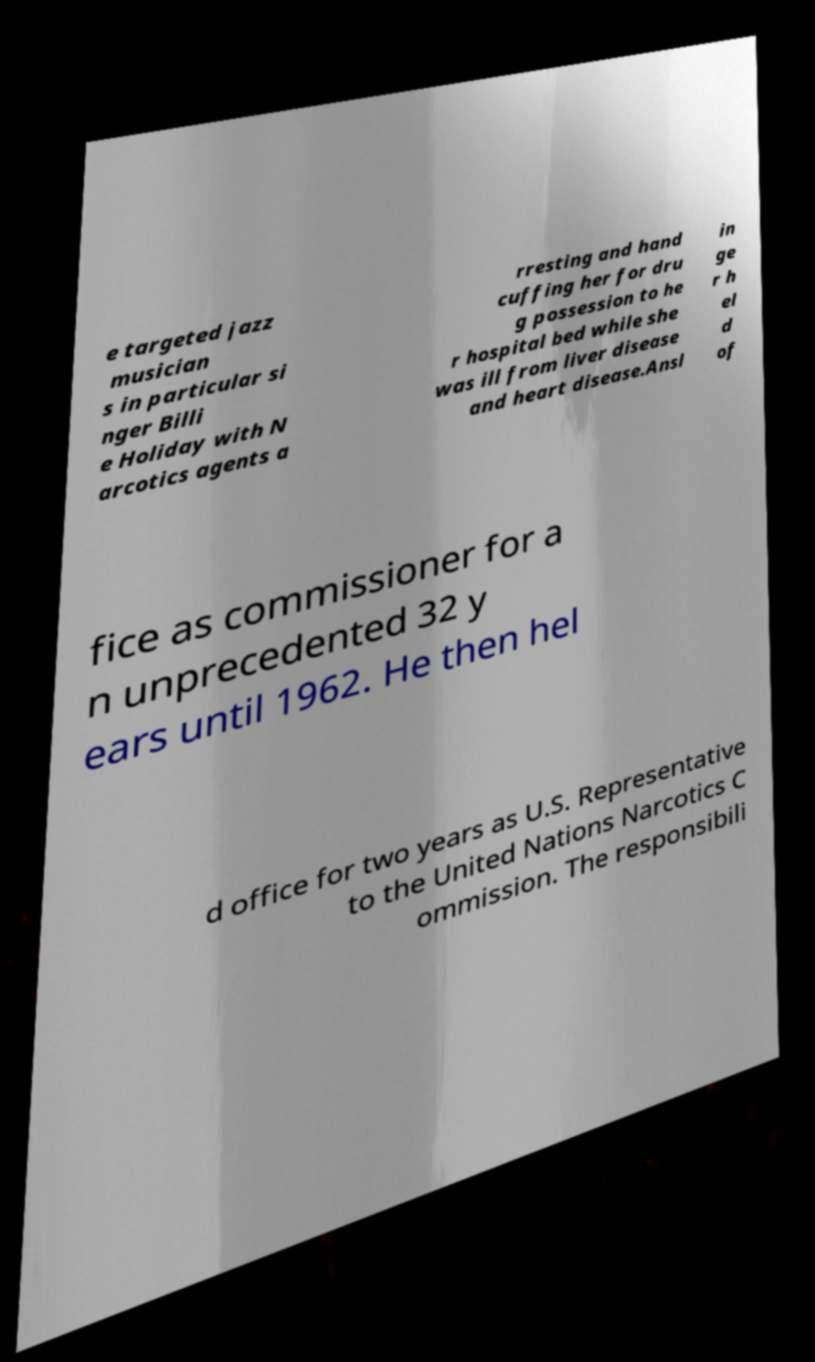Please identify and transcribe the text found in this image. e targeted jazz musician s in particular si nger Billi e Holiday with N arcotics agents a rresting and hand cuffing her for dru g possession to he r hospital bed while she was ill from liver disease and heart disease.Ansl in ge r h el d of fice as commissioner for a n unprecedented 32 y ears until 1962. He then hel d office for two years as U.S. Representative to the United Nations Narcotics C ommission. The responsibili 